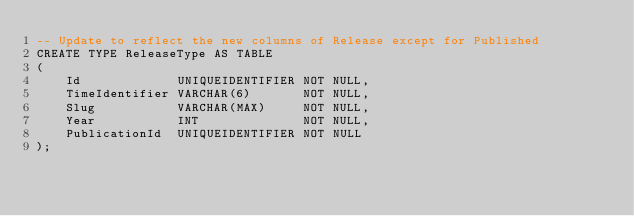Convert code to text. <code><loc_0><loc_0><loc_500><loc_500><_SQL_>-- Update to reflect the new columns of Release except for Published
CREATE TYPE ReleaseType AS TABLE
(
    Id             UNIQUEIDENTIFIER NOT NULL,
    TimeIdentifier VARCHAR(6)       NOT NULL,
    Slug           VARCHAR(MAX)     NOT NULL,
    Year           INT              NOT NULL,
    PublicationId  UNIQUEIDENTIFIER NOT NULL
);</code> 